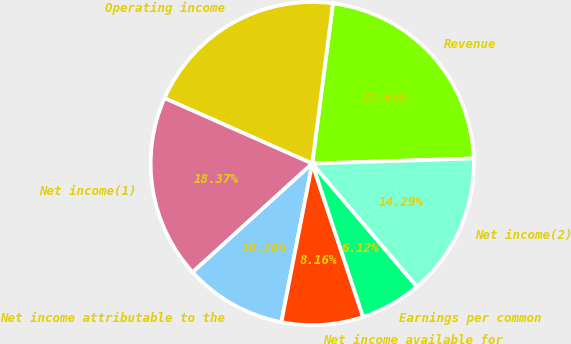<chart> <loc_0><loc_0><loc_500><loc_500><pie_chart><fcel>Revenue<fcel>Operating income<fcel>Net income(1)<fcel>Net income attributable to the<fcel>Net income available for<fcel>Earnings per common<fcel>Net income(2)<nl><fcel>22.45%<fcel>20.41%<fcel>18.37%<fcel>10.2%<fcel>8.16%<fcel>6.12%<fcel>14.29%<nl></chart> 